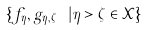<formula> <loc_0><loc_0><loc_500><loc_500>\{ f _ { \eta } , g _ { \eta , \zeta } \ | \eta > \zeta \in \mathcal { X } \}</formula> 